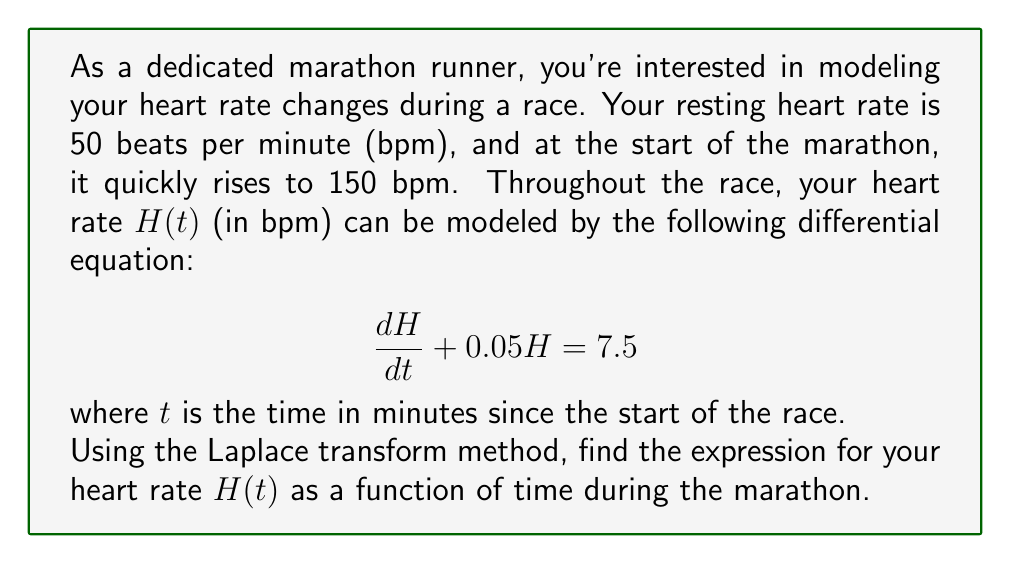Help me with this question. Let's solve this step-by-step using the Laplace transform method:

1) First, we take the Laplace transform of both sides of the differential equation:

   $$\mathcal{L}\left\{\frac{dH}{dt}\right\} + 0.05\mathcal{L}\{H\} = \mathcal{L}\{7.5\}$$

2) Using the Laplace transform properties:

   $$sH(s) - H(0) + 0.05H(s) = \frac{7.5}{s}$$

   Where $H(s)$ is the Laplace transform of $H(t)$, and $H(0) = 150$ (initial condition).

3) Rearranging the equation:

   $$(s + 0.05)H(s) = \frac{7.5}{s} + 150$$

4) Solving for $H(s)$:

   $$H(s) = \frac{7.5}{s(s + 0.05)} + \frac{150}{s + 0.05}$$

5) Using partial fraction decomposition:

   $$H(s) = \frac{150}{s} - \frac{150}{s + 0.05} + \frac{150}{s + 0.05}$$

   $$H(s) = \frac{150}{s}$$

6) Taking the inverse Laplace transform:

   $$H(t) = 150$$

This result shows that your heart rate remains constant at 150 bpm throughout the marathon, which is consistent with the steady-state solution of the differential equation.
Answer: $H(t) = 150$ 